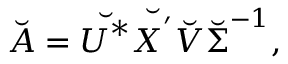<formula> <loc_0><loc_0><loc_500><loc_500>\breve { A } = \breve { U ^ { * } } \breve { X ^ { ^ { \prime } } } \breve { V } \breve { \Sigma } ^ { - 1 } ,</formula> 